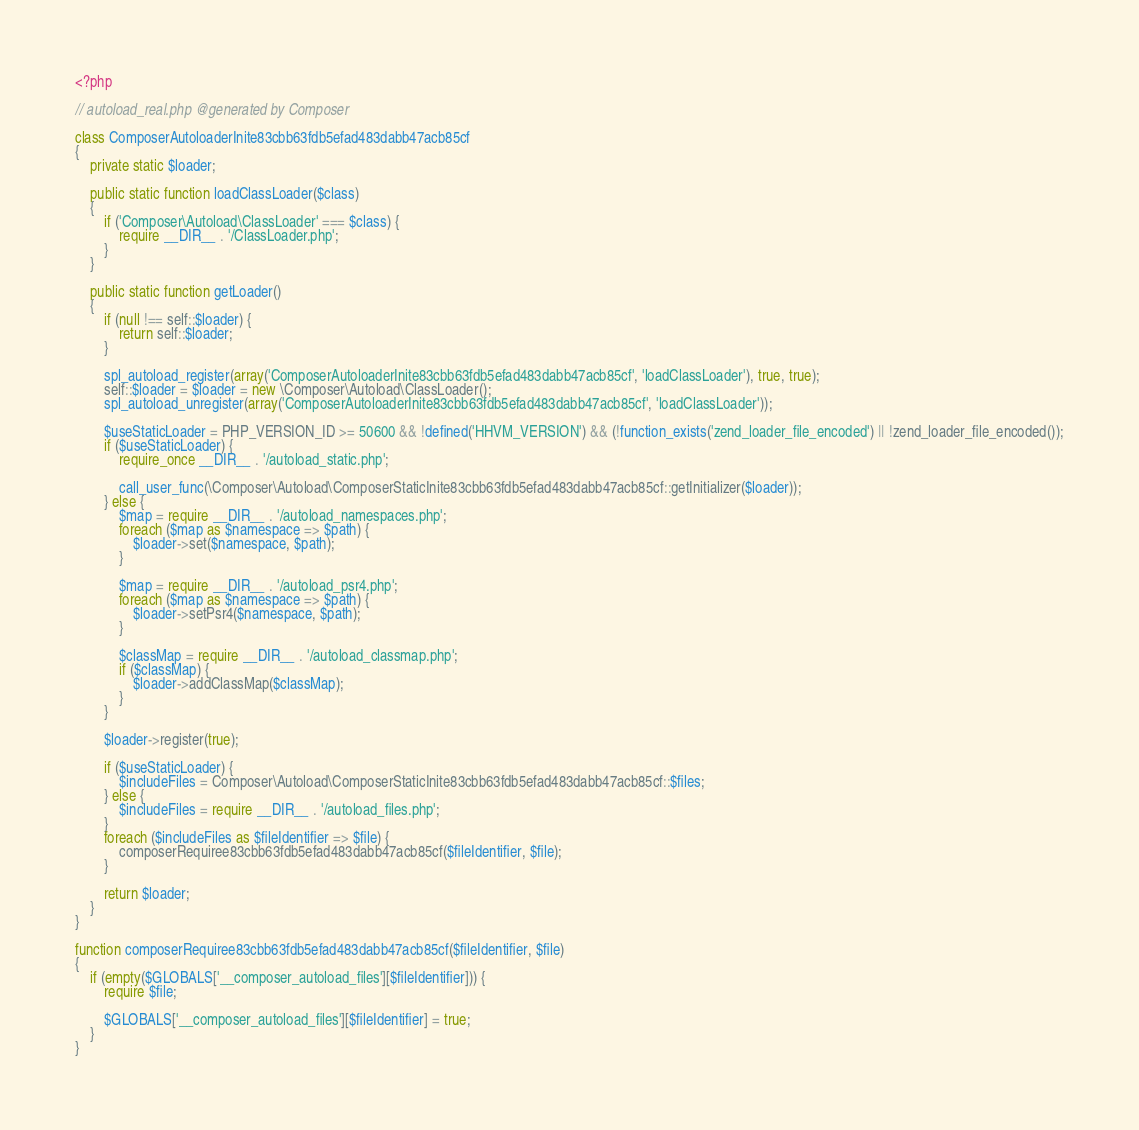<code> <loc_0><loc_0><loc_500><loc_500><_PHP_><?php

// autoload_real.php @generated by Composer

class ComposerAutoloaderInite83cbb63fdb5efad483dabb47acb85cf
{
    private static $loader;

    public static function loadClassLoader($class)
    {
        if ('Composer\Autoload\ClassLoader' === $class) {
            require __DIR__ . '/ClassLoader.php';
        }
    }

    public static function getLoader()
    {
        if (null !== self::$loader) {
            return self::$loader;
        }

        spl_autoload_register(array('ComposerAutoloaderInite83cbb63fdb5efad483dabb47acb85cf', 'loadClassLoader'), true, true);
        self::$loader = $loader = new \Composer\Autoload\ClassLoader();
        spl_autoload_unregister(array('ComposerAutoloaderInite83cbb63fdb5efad483dabb47acb85cf', 'loadClassLoader'));

        $useStaticLoader = PHP_VERSION_ID >= 50600 && !defined('HHVM_VERSION') && (!function_exists('zend_loader_file_encoded') || !zend_loader_file_encoded());
        if ($useStaticLoader) {
            require_once __DIR__ . '/autoload_static.php';

            call_user_func(\Composer\Autoload\ComposerStaticInite83cbb63fdb5efad483dabb47acb85cf::getInitializer($loader));
        } else {
            $map = require __DIR__ . '/autoload_namespaces.php';
            foreach ($map as $namespace => $path) {
                $loader->set($namespace, $path);
            }

            $map = require __DIR__ . '/autoload_psr4.php';
            foreach ($map as $namespace => $path) {
                $loader->setPsr4($namespace, $path);
            }

            $classMap = require __DIR__ . '/autoload_classmap.php';
            if ($classMap) {
                $loader->addClassMap($classMap);
            }
        }

        $loader->register(true);

        if ($useStaticLoader) {
            $includeFiles = Composer\Autoload\ComposerStaticInite83cbb63fdb5efad483dabb47acb85cf::$files;
        } else {
            $includeFiles = require __DIR__ . '/autoload_files.php';
        }
        foreach ($includeFiles as $fileIdentifier => $file) {
            composerRequiree83cbb63fdb5efad483dabb47acb85cf($fileIdentifier, $file);
        }

        return $loader;
    }
}

function composerRequiree83cbb63fdb5efad483dabb47acb85cf($fileIdentifier, $file)
{
    if (empty($GLOBALS['__composer_autoload_files'][$fileIdentifier])) {
        require $file;

        $GLOBALS['__composer_autoload_files'][$fileIdentifier] = true;
    }
}
</code> 